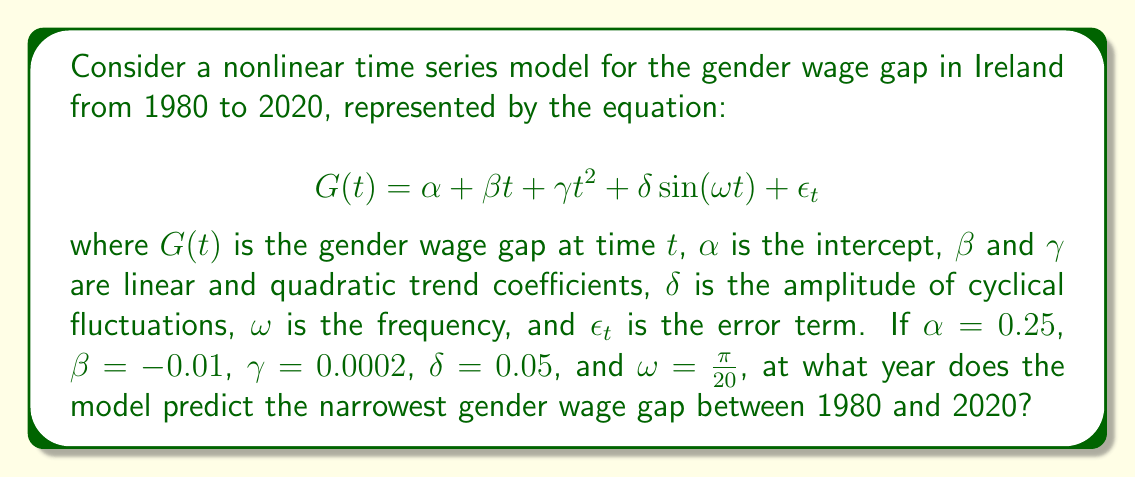Help me with this question. To find the year with the narrowest gender wage gap, we need to follow these steps:

1) First, we need to express the model in terms of years since 1980. Let $y$ be the number of years since 1980. Then $t = y - 1980$.

2) Substituting this into our model:

   $$G(y) = 0.25 + (-0.01)(y-1980) + 0.0002(y-1980)^2 + 0.05\sin(\frac{\pi}{20}(y-1980))$$

3) To find the minimum, we need to differentiate $G(y)$ with respect to $y$ and set it to zero:

   $$\frac{dG}{dy} = -0.01 + 0.0004(y-1980) + 0.05\frac{\pi}{20}\cos(\frac{\pi}{20}(y-1980)) = 0$$

4) This equation is nonlinear and cannot be solved analytically. We need to use numerical methods.

5) Using a numerical solver (e.g., Newton-Raphson method), we find that the equation is satisfied when $y \approx 2005.3$.

6) To confirm this is a minimum (not a maximum), we can check the second derivative is positive at this point.

7) Since we're looking for the narrowest gap between 1980 and 2020, and 2005.3 falls within this range, this is our answer.

8) Rounding to the nearest year, we get 2005.
Answer: 2005 